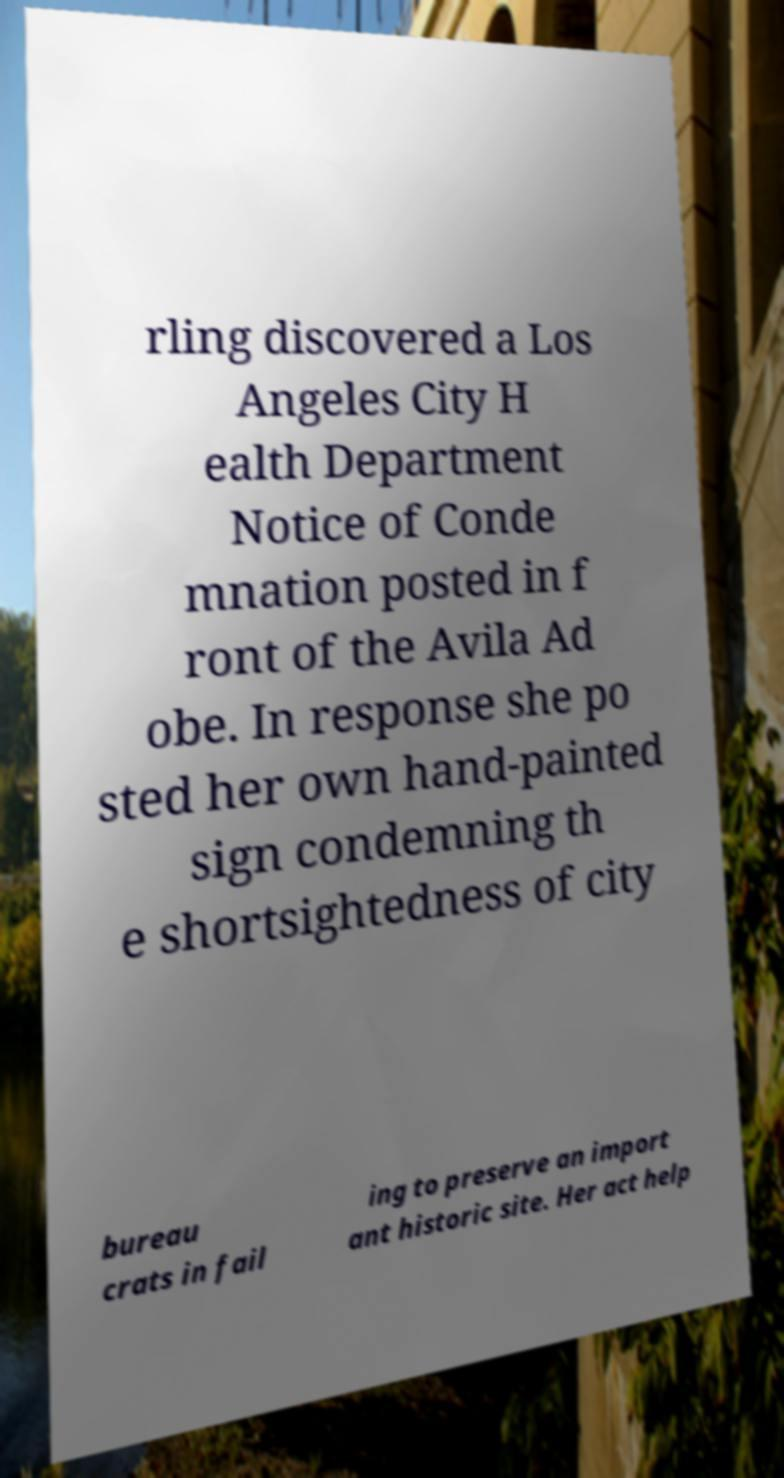What messages or text are displayed in this image? I need them in a readable, typed format. rling discovered a Los Angeles City H ealth Department Notice of Conde mnation posted in f ront of the Avila Ad obe. In response she po sted her own hand-painted sign condemning th e shortsightedness of city bureau crats in fail ing to preserve an import ant historic site. Her act help 